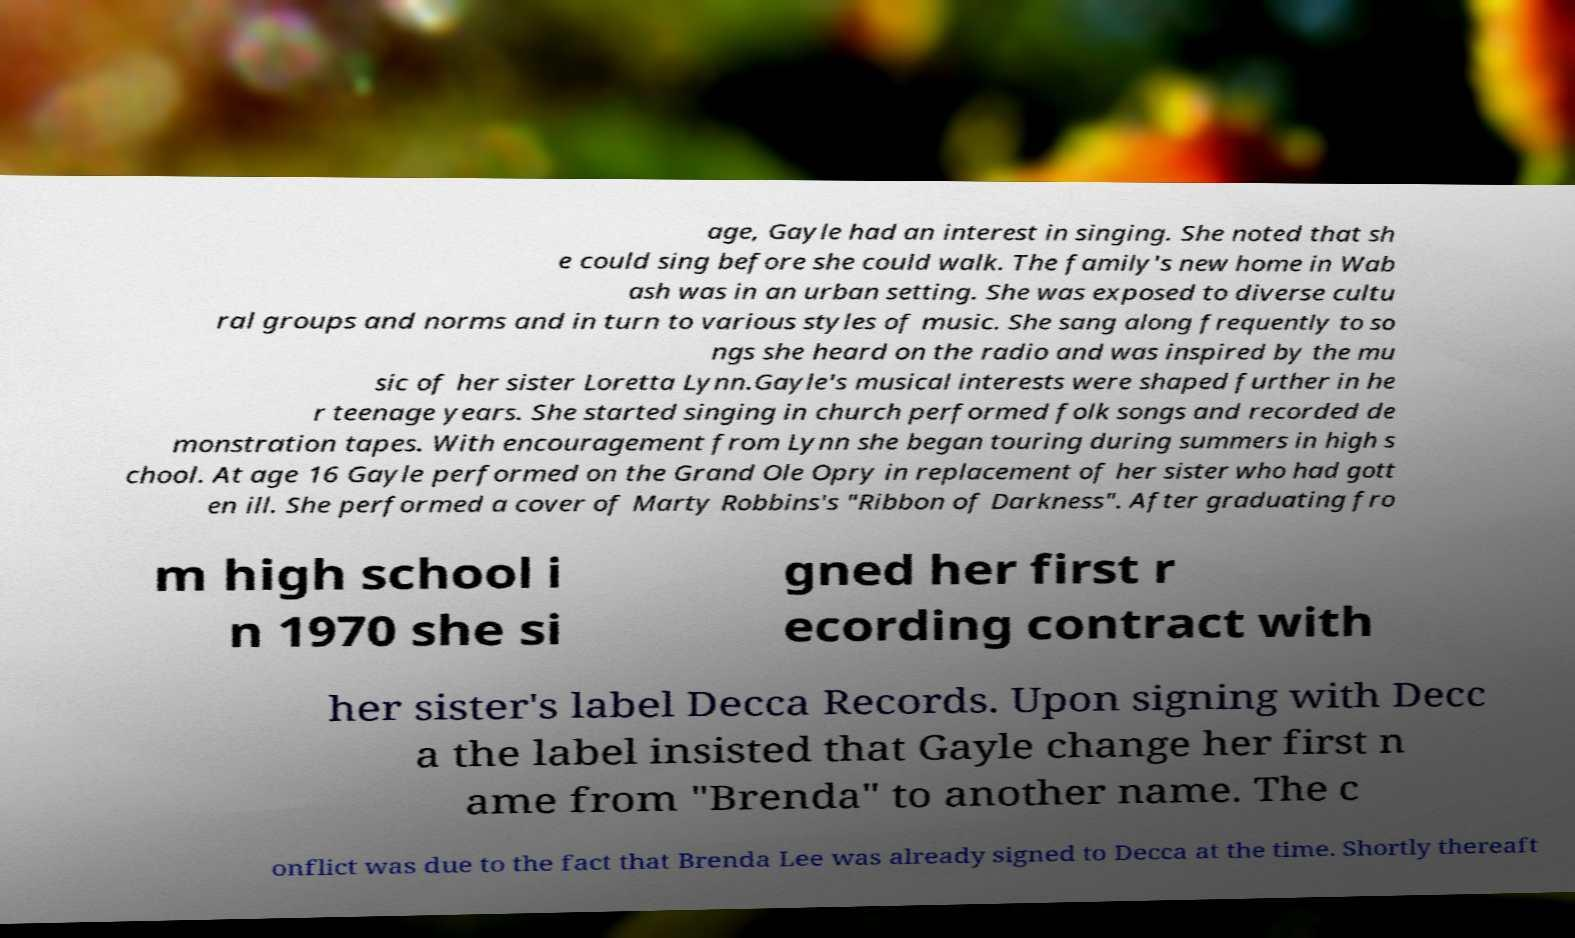Can you read and provide the text displayed in the image?This photo seems to have some interesting text. Can you extract and type it out for me? age, Gayle had an interest in singing. She noted that sh e could sing before she could walk. The family's new home in Wab ash was in an urban setting. She was exposed to diverse cultu ral groups and norms and in turn to various styles of music. She sang along frequently to so ngs she heard on the radio and was inspired by the mu sic of her sister Loretta Lynn.Gayle's musical interests were shaped further in he r teenage years. She started singing in church performed folk songs and recorded de monstration tapes. With encouragement from Lynn she began touring during summers in high s chool. At age 16 Gayle performed on the Grand Ole Opry in replacement of her sister who had gott en ill. She performed a cover of Marty Robbins's "Ribbon of Darkness". After graduating fro m high school i n 1970 she si gned her first r ecording contract with her sister's label Decca Records. Upon signing with Decc a the label insisted that Gayle change her first n ame from "Brenda" to another name. The c onflict was due to the fact that Brenda Lee was already signed to Decca at the time. Shortly thereaft 